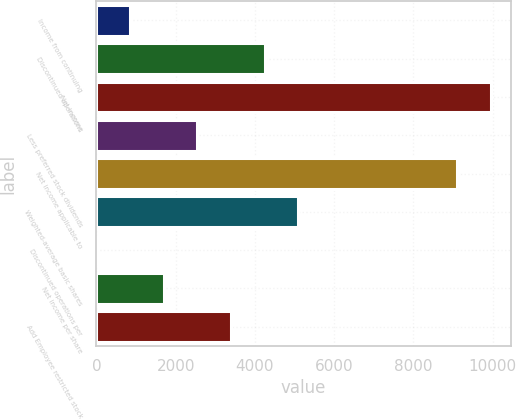Convert chart to OTSL. <chart><loc_0><loc_0><loc_500><loc_500><bar_chart><fcel>Income from continuing<fcel>Discontinued operations<fcel>Net income<fcel>Less preferred stock dividends<fcel>Net income applicable to<fcel>Weighted-average basic shares<fcel>Discontinued operations per<fcel>Net income per share<fcel>Add Employee restricted stock<nl><fcel>848.36<fcel>4241.52<fcel>9950.58<fcel>2544.94<fcel>9102.29<fcel>5089.81<fcel>0.07<fcel>1696.65<fcel>3393.23<nl></chart> 